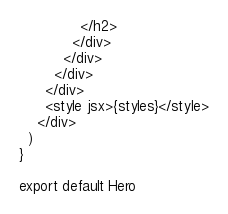<code> <loc_0><loc_0><loc_500><loc_500><_JavaScript_>              </h2>
            </div>
          </div>
        </div>
      </div>
      <style jsx>{styles}</style>
    </div>
  )
}

export default Hero
</code> 